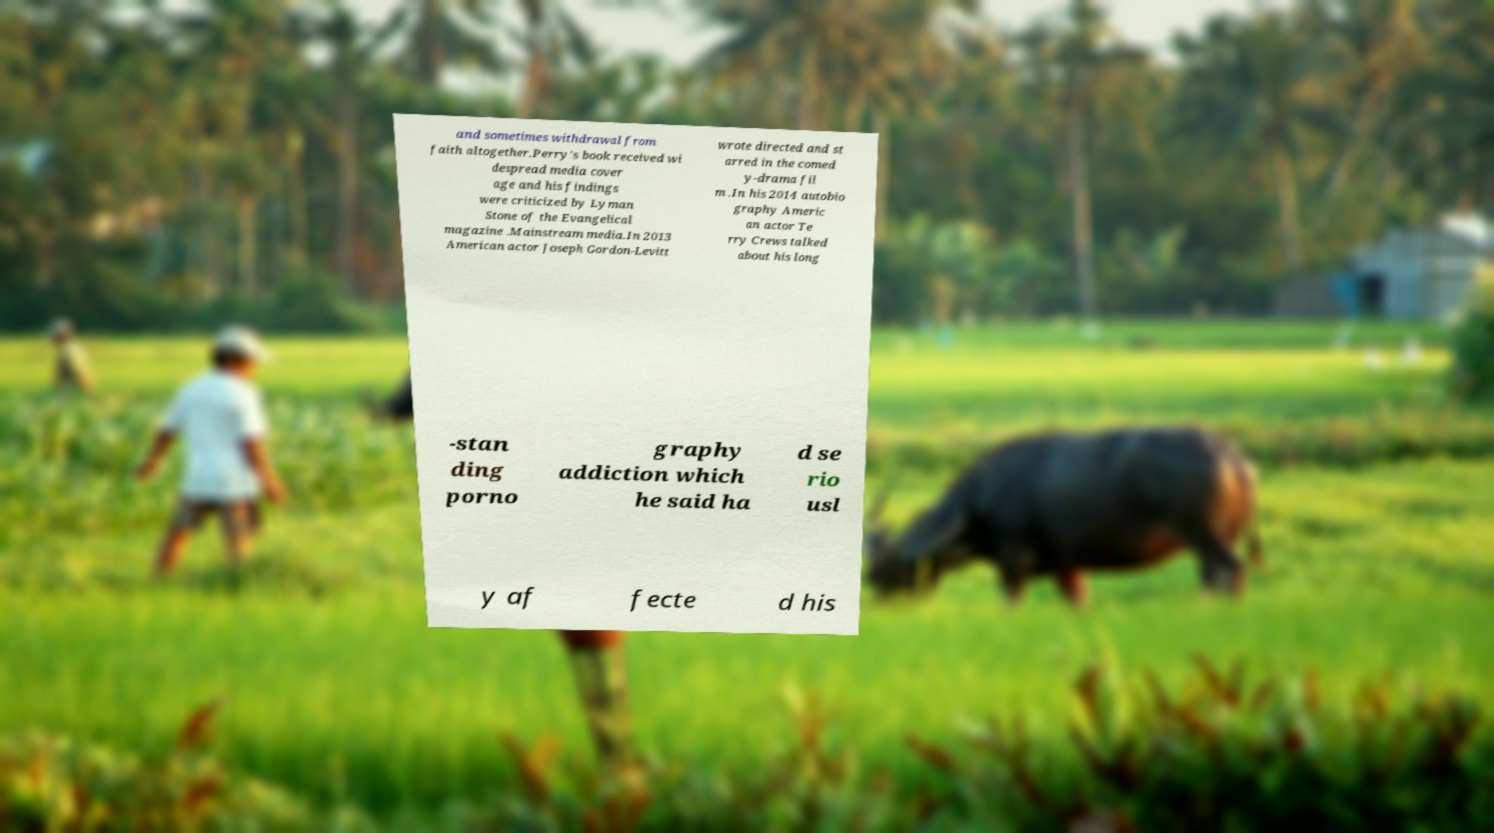What messages or text are displayed in this image? I need them in a readable, typed format. and sometimes withdrawal from faith altogether.Perry's book received wi despread media cover age and his findings were criticized by Lyman Stone of the Evangelical magazine .Mainstream media.In 2013 American actor Joseph Gordon-Levitt wrote directed and st arred in the comed y-drama fil m .In his 2014 autobio graphy Americ an actor Te rry Crews talked about his long -stan ding porno graphy addiction which he said ha d se rio usl y af fecte d his 